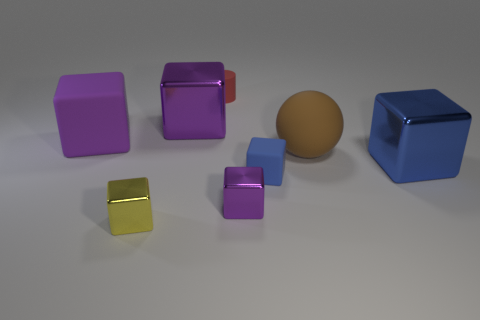Is the number of purple cubes that are to the left of the small blue block greater than the number of large things that are to the left of the large purple metallic cube?
Give a very brief answer. Yes. How many yellow shiny objects are the same shape as the blue matte object?
Ensure brevity in your answer.  1. There is a blue block that is the same size as the sphere; what material is it?
Make the answer very short. Metal. What is the shape of the tiny thing that is both on the left side of the small purple shiny thing and behind the yellow metal cube?
Provide a succinct answer. Cylinder. There is a purple shiny block that is in front of the blue block in front of the large blue metal cube; how big is it?
Offer a very short reply. Small. How many things are either tiny red rubber things or large metal cubes in front of the big matte cube?
Offer a terse response. 2. Is the shape of the big rubber object that is to the left of the brown matte sphere the same as  the large brown thing?
Offer a terse response. No. There is a object that is to the left of the tiny cube left of the tiny purple object; how many purple things are behind it?
Ensure brevity in your answer.  1. Is there any other thing that has the same shape as the big blue object?
Your answer should be compact. Yes. How many objects are blue rubber things or rubber cylinders?
Ensure brevity in your answer.  2. 